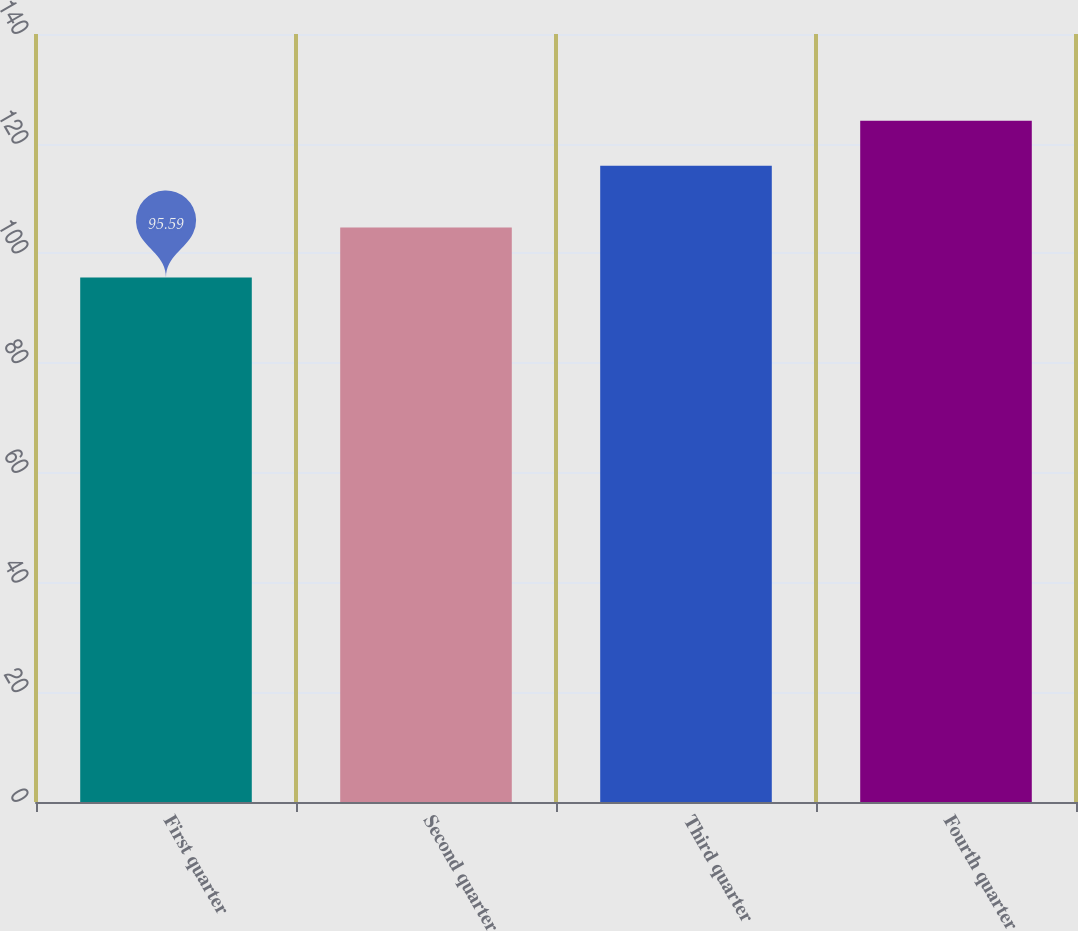Convert chart. <chart><loc_0><loc_0><loc_500><loc_500><bar_chart><fcel>First quarter<fcel>Second quarter<fcel>Third quarter<fcel>Fourth quarter<nl><fcel>95.59<fcel>104.74<fcel>115.97<fcel>124.17<nl></chart> 